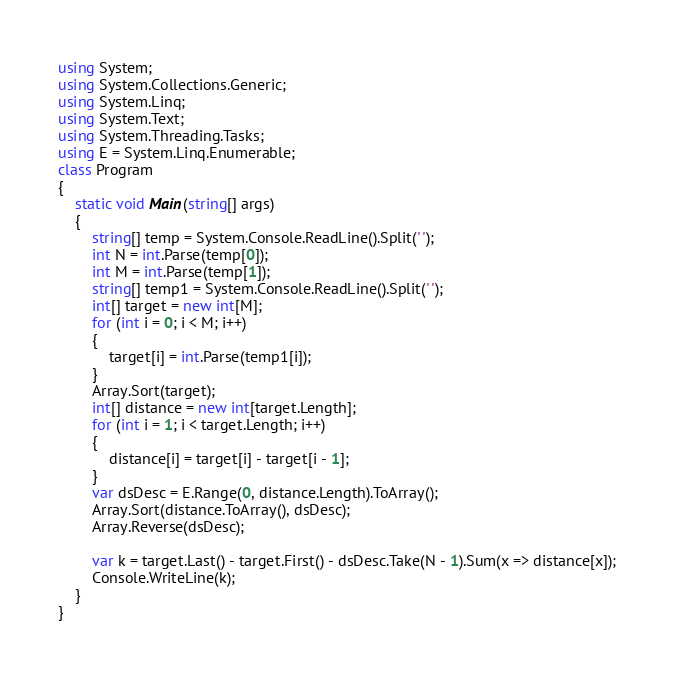Convert code to text. <code><loc_0><loc_0><loc_500><loc_500><_C#_>using System;
using System.Collections.Generic;
using System.Linq;
using System.Text;
using System.Threading.Tasks;
using E = System.Linq.Enumerable;
class Program
{
    static void Main(string[] args)
    {
        string[] temp = System.Console.ReadLine().Split(' ');
        int N = int.Parse(temp[0]);
        int M = int.Parse(temp[1]);
        string[] temp1 = System.Console.ReadLine().Split(' ');
        int[] target = new int[M];
        for (int i = 0; i < M; i++)
        {
            target[i] = int.Parse(temp1[i]);
        }
        Array.Sort(target);
        int[] distance = new int[target.Length];
        for (int i = 1; i < target.Length; i++)
        {
            distance[i] = target[i] - target[i - 1];
        }
        var dsDesc = E.Range(0, distance.Length).ToArray();
        Array.Sort(distance.ToArray(), dsDesc);
        Array.Reverse(dsDesc);

        var k = target.Last() - target.First() - dsDesc.Take(N - 1).Sum(x => distance[x]);
        Console.WriteLine(k);
    }
}</code> 